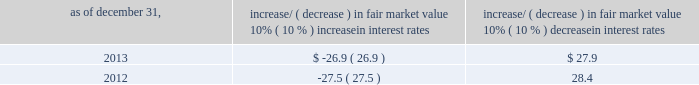Item 7a .
Quantitative and qualitative disclosures about market risk ( amounts in millions ) in the normal course of business , we are exposed to market risks related to interest rates , foreign currency rates and certain balance sheet items .
From time to time , we use derivative instruments , pursuant to established guidelines and policies , to manage some portion of these risks .
Derivative instruments utilized in our hedging activities are viewed as risk management tools and are not used for trading or speculative purposes .
Interest rates our exposure to market risk for changes in interest rates relates primarily to the fair market value and cash flows of our debt obligations .
The majority of our debt ( approximately 89% ( 89 % ) and 93% ( 93 % ) as of december 31 , 2013 and 2012 , respectively ) bears interest at fixed rates .
We do have debt with variable interest rates , but a 10% ( 10 % ) increase or decrease in interest rates would not be material to our interest expense or cash flows .
The fair market value of our debt is sensitive to changes in interest rates , and the impact of a 10% ( 10 % ) change in interest rates is summarized below .
Increase/ ( decrease ) in fair market value as of december 31 , 10% ( 10 % ) increase in interest rates 10% ( 10 % ) decrease in interest rates .
We have used interest rate swaps for risk management purposes to manage our exposure to changes in interest rates .
We do not have any interest rate swaps outstanding as of december 31 , 2013 .
We had $ 1642.1 of cash , cash equivalents and marketable securities as of december 31 , 2013 that we generally invest in conservative , short-term bank deposits or securities .
The interest income generated from these investments is subject to both domestic and foreign interest rate movements .
During 2013 and 2012 , we had interest income of $ 24.7 and $ 29.5 , respectively .
Based on our 2013 results , a 100-basis-point increase or decrease in interest rates would affect our interest income by approximately $ 16.4 , assuming that all cash , cash equivalents and marketable securities are impacted in the same manner and balances remain constant from year-end 2013 levels .
Foreign currency rates we are subject to translation and transaction risks related to changes in foreign currency exchange rates .
Since we report revenues and expenses in u.s .
Dollars , changes in exchange rates may either positively or negatively affect our consolidated revenues and expenses ( as expressed in u.s .
Dollars ) from foreign operations .
The primary foreign currencies that impacted our results during 2013 were the australian dollar , brazilian real , euro , japanese yen and the south african rand .
Based on 2013 exchange rates and operating results , if the u.s .
Dollar were to strengthen or weaken by 10% ( 10 % ) , we currently estimate operating income would decrease or increase between 3% ( 3 % ) and 4% ( 4 % ) , assuming that all currencies are impacted in the same manner and our international revenue and expenses remain constant at 2013 levels .
The functional currency of our foreign operations is generally their respective local currency .
Assets and liabilities are translated at the exchange rates in effect at the balance sheet date , and revenues and expenses are translated at the average exchange rates during the period presented .
The resulting translation adjustments are recorded as a component of accumulated other comprehensive loss , net of tax , in the stockholders 2019 equity section of our consolidated balance sheets .
Our foreign subsidiaries generally collect revenues and pay expenses in their functional currency , mitigating transaction risk .
However , certain subsidiaries may enter into transactions in currencies other than their functional currency .
Assets and liabilities denominated in currencies other than the functional currency are susceptible to movements in foreign currency until final settlement .
Currency transaction gains or losses primarily arising from transactions in currencies other than the functional currency are included in office and general expenses .
We have not entered into a material amount of foreign currency forward exchange contracts or other derivative financial instruments to hedge the effects of potential adverse fluctuations in foreign currency exchange rates. .
What is the statistical interval that interest income can be affected during the next year based on the data from 2013? 
Rationale: to find a statistical interval , one must take the data from the year before ( 24.7 ) and add the amount that could change ( 16.4 ) and subtract the amount that could change . this would give you the interval that it would be in-between .
Computations: (24.7 - 16.4)
Answer: 8.3. 